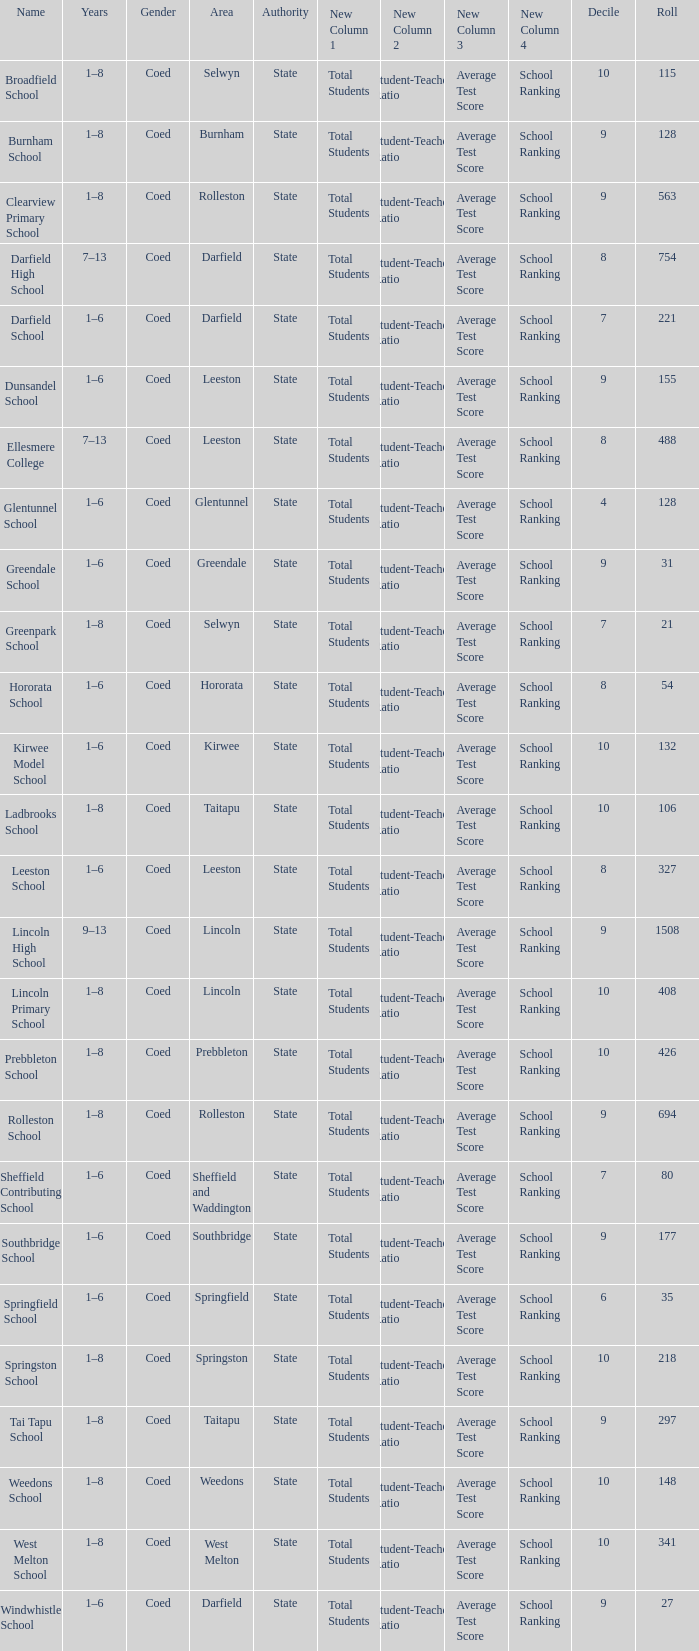What is the total of the roll with a Decile of 8, and an Area of hororata? 54.0. Would you be able to parse every entry in this table? {'header': ['Name', 'Years', 'Gender', 'Area', 'Authority', 'New Column 1', 'New Column 2', 'New Column 3', 'New Column 4', 'Decile', 'Roll'], 'rows': [['Broadfield School', '1–8', 'Coed', 'Selwyn', 'State', 'Total Students', 'Student-Teacher Ratio', 'Average Test Score', 'School Ranking', '10', '115'], ['Burnham School', '1–8', 'Coed', 'Burnham', 'State', 'Total Students', 'Student-Teacher Ratio', 'Average Test Score', 'School Ranking', '9', '128'], ['Clearview Primary School', '1–8', 'Coed', 'Rolleston', 'State', 'Total Students', 'Student-Teacher Ratio', 'Average Test Score', 'School Ranking', '9', '563'], ['Darfield High School', '7–13', 'Coed', 'Darfield', 'State', 'Total Students', 'Student-Teacher Ratio', 'Average Test Score', 'School Ranking', '8', '754'], ['Darfield School', '1–6', 'Coed', 'Darfield', 'State', 'Total Students', 'Student-Teacher Ratio', 'Average Test Score', 'School Ranking', '7', '221'], ['Dunsandel School', '1–6', 'Coed', 'Leeston', 'State', 'Total Students', 'Student-Teacher Ratio', 'Average Test Score', 'School Ranking', '9', '155'], ['Ellesmere College', '7–13', 'Coed', 'Leeston', 'State', 'Total Students', 'Student-Teacher Ratio', 'Average Test Score', 'School Ranking', '8', '488'], ['Glentunnel School', '1–6', 'Coed', 'Glentunnel', 'State', 'Total Students', 'Student-Teacher Ratio', 'Average Test Score', 'School Ranking', '4', '128'], ['Greendale School', '1–6', 'Coed', 'Greendale', 'State', 'Total Students', 'Student-Teacher Ratio', 'Average Test Score', 'School Ranking', '9', '31'], ['Greenpark School', '1–8', 'Coed', 'Selwyn', 'State', 'Total Students', 'Student-Teacher Ratio', 'Average Test Score', 'School Ranking', '7', '21'], ['Hororata School', '1–6', 'Coed', 'Hororata', 'State', 'Total Students', 'Student-Teacher Ratio', 'Average Test Score', 'School Ranking', '8', '54'], ['Kirwee Model School', '1–6', 'Coed', 'Kirwee', 'State', 'Total Students', 'Student-Teacher Ratio', 'Average Test Score', 'School Ranking', '10', '132'], ['Ladbrooks School', '1–8', 'Coed', 'Taitapu', 'State', 'Total Students', 'Student-Teacher Ratio', 'Average Test Score', 'School Ranking', '10', '106'], ['Leeston School', '1–6', 'Coed', 'Leeston', 'State', 'Total Students', 'Student-Teacher Ratio', 'Average Test Score', 'School Ranking', '8', '327'], ['Lincoln High School', '9–13', 'Coed', 'Lincoln', 'State', 'Total Students', 'Student-Teacher Ratio', 'Average Test Score', 'School Ranking', '9', '1508'], ['Lincoln Primary School', '1–8', 'Coed', 'Lincoln', 'State', 'Total Students', 'Student-Teacher Ratio', 'Average Test Score', 'School Ranking', '10', '408'], ['Prebbleton School', '1–8', 'Coed', 'Prebbleton', 'State', 'Total Students', 'Student-Teacher Ratio', 'Average Test Score', 'School Ranking', '10', '426'], ['Rolleston School', '1–8', 'Coed', 'Rolleston', 'State', 'Total Students', 'Student-Teacher Ratio', 'Average Test Score', 'School Ranking', '9', '694'], ['Sheffield Contributing School', '1–6', 'Coed', 'Sheffield and Waddington', 'State', 'Total Students', 'Student-Teacher Ratio', 'Average Test Score', 'School Ranking', '7', '80'], ['Southbridge School', '1–6', 'Coed', 'Southbridge', 'State', 'Total Students', 'Student-Teacher Ratio', 'Average Test Score', 'School Ranking', '9', '177'], ['Springfield School', '1–6', 'Coed', 'Springfield', 'State', 'Total Students', 'Student-Teacher Ratio', 'Average Test Score', 'School Ranking', '6', '35'], ['Springston School', '1–8', 'Coed', 'Springston', 'State', 'Total Students', 'Student-Teacher Ratio', 'Average Test Score', 'School Ranking', '10', '218'], ['Tai Tapu School', '1–8', 'Coed', 'Taitapu', 'State', 'Total Students', 'Student-Teacher Ratio', 'Average Test Score', 'School Ranking', '9', '297'], ['Weedons School', '1–8', 'Coed', 'Weedons', 'State', 'Total Students', 'Student-Teacher Ratio', 'Average Test Score', 'School Ranking', '10', '148'], ['West Melton School', '1–8', 'Coed', 'West Melton', 'State', 'Total Students', 'Student-Teacher Ratio', 'Average Test Score', 'School Ranking', '10', '341'], ['Windwhistle School', '1–6', 'Coed', 'Darfield', 'State', 'Total Students', 'Student-Teacher Ratio', 'Average Test Score', 'School Ranking', '9', '27']]} 